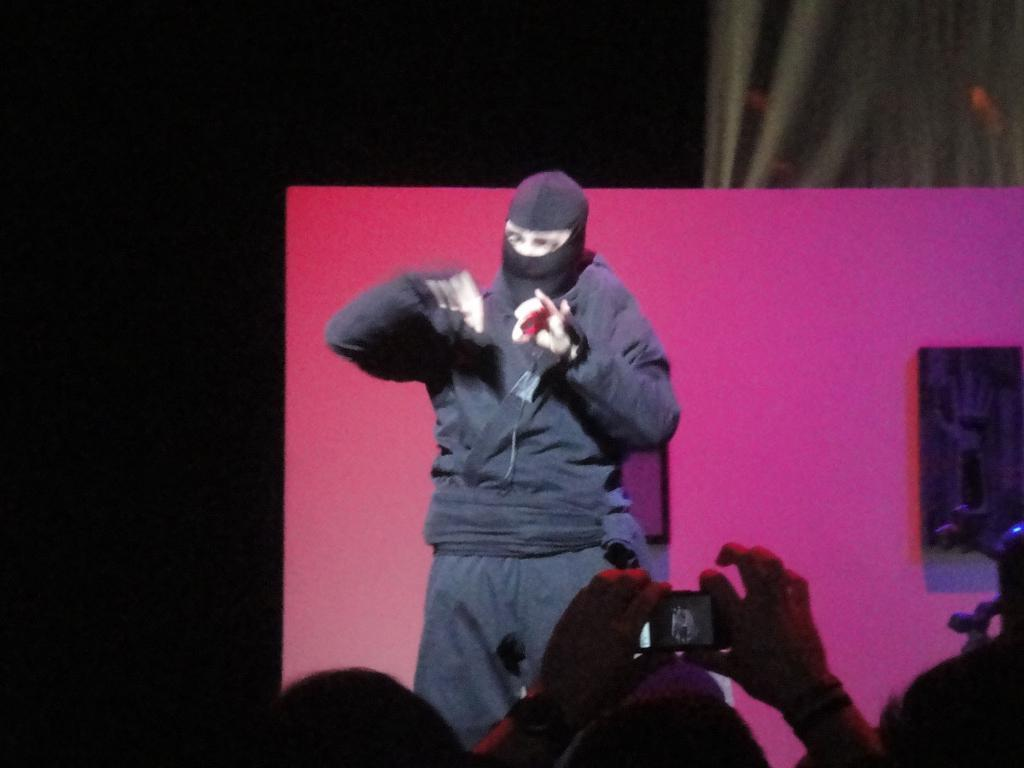How many people are in the image? There are multiple persons in the image. What is the person holding in the image? There is a person holding a mobile in the image. What else can be seen in the image besides the people? There is a board and a cloth in the image. What is the color of the background in the image? The background of the image is dark. What type of attraction can be seen in the image? There is no attraction present in the image; it features multiple persons, a board, a cloth, and a person holding a mobile. What type of cushion is being used by the person in the image? There is no cushion present in the image. 